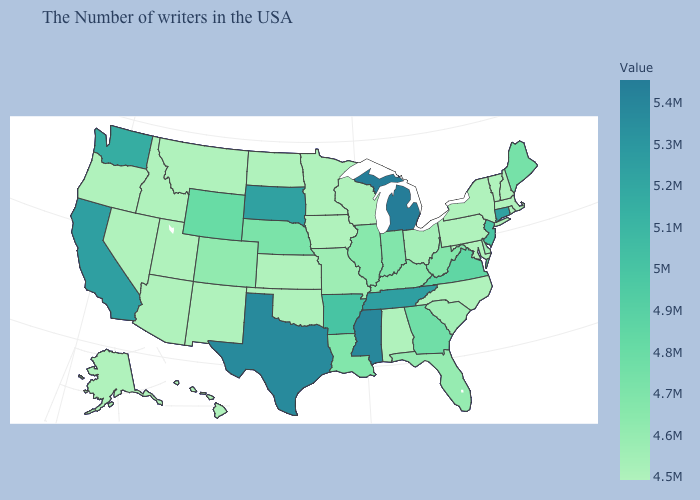Which states have the highest value in the USA?
Write a very short answer. Michigan. Does Indiana have the highest value in the MidWest?
Give a very brief answer. No. Which states have the lowest value in the Northeast?
Keep it brief. Massachusetts, Rhode Island, New Hampshire, Vermont, New York, Pennsylvania. Does California have the highest value in the USA?
Keep it brief. No. Which states hav the highest value in the MidWest?
Be succinct. Michigan. Does Alabama have the highest value in the South?
Quick response, please. No. Does Illinois have a higher value than Alaska?
Answer briefly. Yes. Which states have the lowest value in the West?
Write a very short answer. New Mexico, Utah, Montana, Arizona, Idaho, Nevada, Oregon, Alaska, Hawaii. 